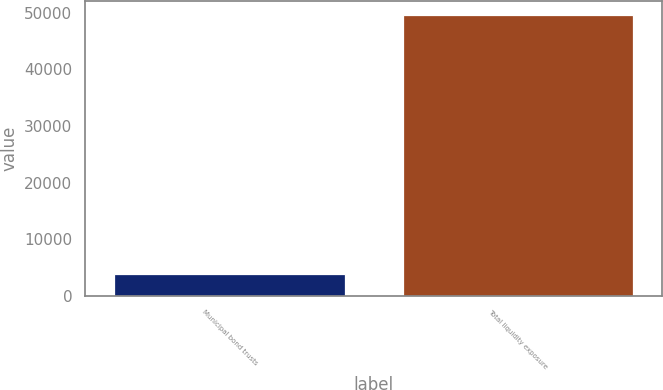Convert chart to OTSL. <chart><loc_0><loc_0><loc_500><loc_500><bar_chart><fcel>Municipal bond trusts<fcel>Total liquidity exposure<nl><fcel>3872<fcel>49651<nl></chart> 